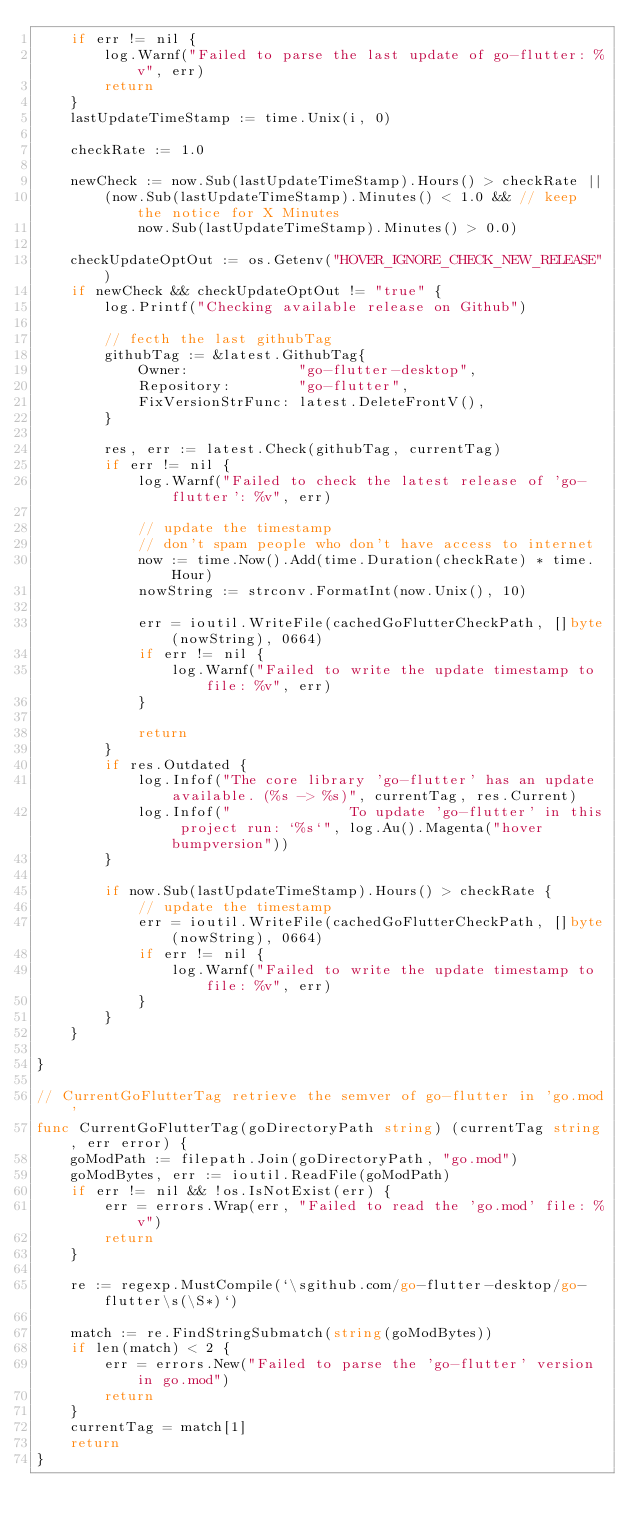<code> <loc_0><loc_0><loc_500><loc_500><_Go_>	if err != nil {
		log.Warnf("Failed to parse the last update of go-flutter: %v", err)
		return
	}
	lastUpdateTimeStamp := time.Unix(i, 0)

	checkRate := 1.0

	newCheck := now.Sub(lastUpdateTimeStamp).Hours() > checkRate ||
		(now.Sub(lastUpdateTimeStamp).Minutes() < 1.0 && // keep the notice for X Minutes
			now.Sub(lastUpdateTimeStamp).Minutes() > 0.0)

	checkUpdateOptOut := os.Getenv("HOVER_IGNORE_CHECK_NEW_RELEASE")
	if newCheck && checkUpdateOptOut != "true" {
		log.Printf("Checking available release on Github")

		// fecth the last githubTag
		githubTag := &latest.GithubTag{
			Owner:             "go-flutter-desktop",
			Repository:        "go-flutter",
			FixVersionStrFunc: latest.DeleteFrontV(),
		}

		res, err := latest.Check(githubTag, currentTag)
		if err != nil {
			log.Warnf("Failed to check the latest release of 'go-flutter': %v", err)

			// update the timestamp
			// don't spam people who don't have access to internet
			now := time.Now().Add(time.Duration(checkRate) * time.Hour)
			nowString := strconv.FormatInt(now.Unix(), 10)

			err = ioutil.WriteFile(cachedGoFlutterCheckPath, []byte(nowString), 0664)
			if err != nil {
				log.Warnf("Failed to write the update timestamp to file: %v", err)
			}

			return
		}
		if res.Outdated {
			log.Infof("The core library 'go-flutter' has an update available. (%s -> %s)", currentTag, res.Current)
			log.Infof("              To update 'go-flutter' in this project run: `%s`", log.Au().Magenta("hover bumpversion"))
		}

		if now.Sub(lastUpdateTimeStamp).Hours() > checkRate {
			// update the timestamp
			err = ioutil.WriteFile(cachedGoFlutterCheckPath, []byte(nowString), 0664)
			if err != nil {
				log.Warnf("Failed to write the update timestamp to file: %v", err)
			}
		}
	}

}

// CurrentGoFlutterTag retrieve the semver of go-flutter in 'go.mod'
func CurrentGoFlutterTag(goDirectoryPath string) (currentTag string, err error) {
	goModPath := filepath.Join(goDirectoryPath, "go.mod")
	goModBytes, err := ioutil.ReadFile(goModPath)
	if err != nil && !os.IsNotExist(err) {
		err = errors.Wrap(err, "Failed to read the 'go.mod' file: %v")
		return
	}

	re := regexp.MustCompile(`\sgithub.com/go-flutter-desktop/go-flutter\s(\S*)`)

	match := re.FindStringSubmatch(string(goModBytes))
	if len(match) < 2 {
		err = errors.New("Failed to parse the 'go-flutter' version in go.mod")
		return
	}
	currentTag = match[1]
	return
}
</code> 